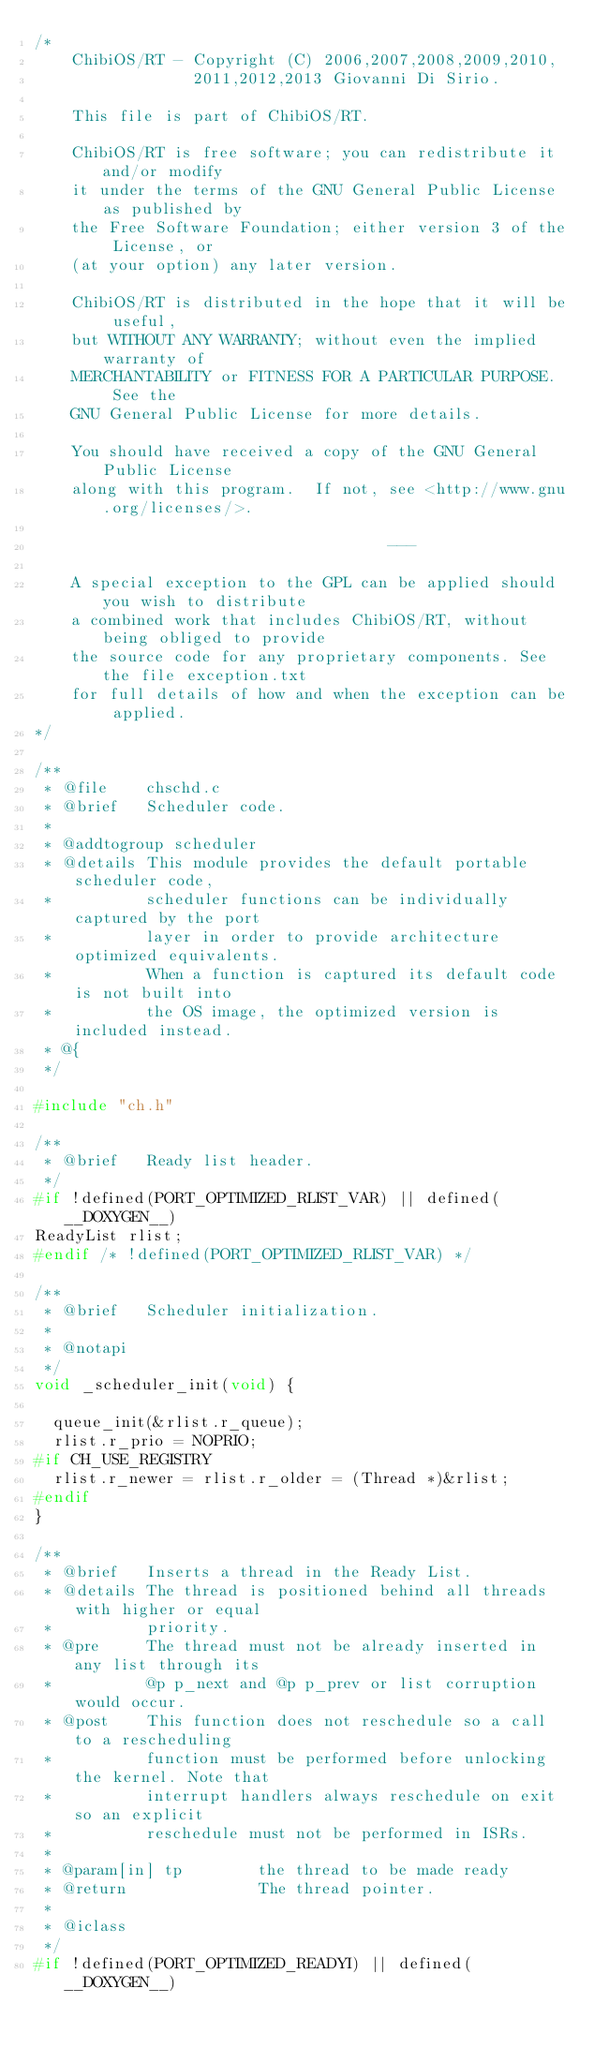Convert code to text. <code><loc_0><loc_0><loc_500><loc_500><_C_>/*
    ChibiOS/RT - Copyright (C) 2006,2007,2008,2009,2010,
                 2011,2012,2013 Giovanni Di Sirio.

    This file is part of ChibiOS/RT.

    ChibiOS/RT is free software; you can redistribute it and/or modify
    it under the terms of the GNU General Public License as published by
    the Free Software Foundation; either version 3 of the License, or
    (at your option) any later version.

    ChibiOS/RT is distributed in the hope that it will be useful,
    but WITHOUT ANY WARRANTY; without even the implied warranty of
    MERCHANTABILITY or FITNESS FOR A PARTICULAR PURPOSE.  See the
    GNU General Public License for more details.

    You should have received a copy of the GNU General Public License
    along with this program.  If not, see <http://www.gnu.org/licenses/>.

                                      ---

    A special exception to the GPL can be applied should you wish to distribute
    a combined work that includes ChibiOS/RT, without being obliged to provide
    the source code for any proprietary components. See the file exception.txt
    for full details of how and when the exception can be applied.
*/

/**
 * @file    chschd.c
 * @brief   Scheduler code.
 *
 * @addtogroup scheduler
 * @details This module provides the default portable scheduler code,
 *          scheduler functions can be individually captured by the port
 *          layer in order to provide architecture optimized equivalents.
 *          When a function is captured its default code is not built into
 *          the OS image, the optimized version is included instead.
 * @{
 */

#include "ch.h"

/**
 * @brief   Ready list header.
 */
#if !defined(PORT_OPTIMIZED_RLIST_VAR) || defined(__DOXYGEN__)
ReadyList rlist;
#endif /* !defined(PORT_OPTIMIZED_RLIST_VAR) */

/**
 * @brief   Scheduler initialization.
 *
 * @notapi
 */
void _scheduler_init(void) {

  queue_init(&rlist.r_queue);
  rlist.r_prio = NOPRIO;
#if CH_USE_REGISTRY
  rlist.r_newer = rlist.r_older = (Thread *)&rlist;
#endif
}

/**
 * @brief   Inserts a thread in the Ready List.
 * @details The thread is positioned behind all threads with higher or equal
 *          priority.
 * @pre     The thread must not be already inserted in any list through its
 *          @p p_next and @p p_prev or list corruption would occur.
 * @post    This function does not reschedule so a call to a rescheduling
 *          function must be performed before unlocking the kernel. Note that
 *          interrupt handlers always reschedule on exit so an explicit
 *          reschedule must not be performed in ISRs.
 *
 * @param[in] tp        the thread to be made ready
 * @return              The thread pointer.
 *
 * @iclass
 */
#if !defined(PORT_OPTIMIZED_READYI) || defined(__DOXYGEN__)</code> 